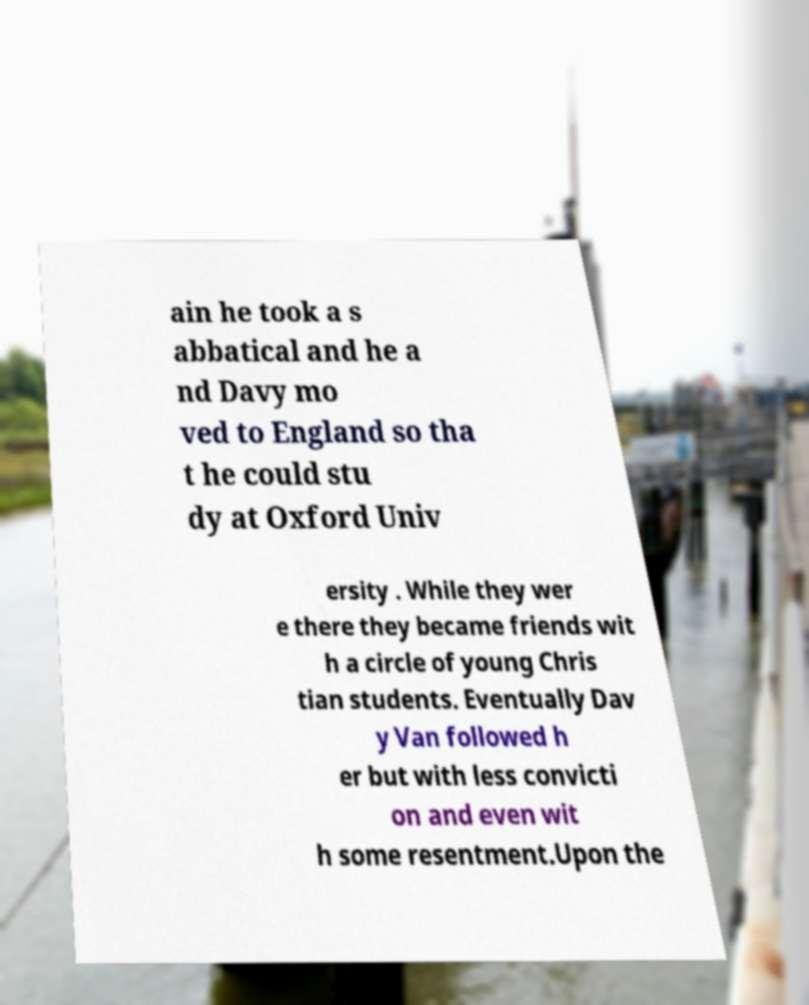Please identify and transcribe the text found in this image. ain he took a s abbatical and he a nd Davy mo ved to England so tha t he could stu dy at Oxford Univ ersity . While they wer e there they became friends wit h a circle of young Chris tian students. Eventually Dav y Van followed h er but with less convicti on and even wit h some resentment.Upon the 